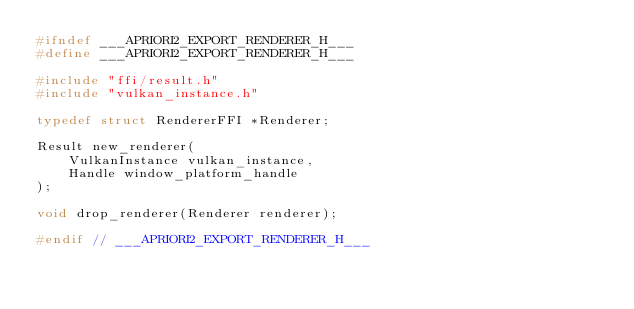Convert code to text. <code><loc_0><loc_0><loc_500><loc_500><_C_>#ifndef ___APRIORI2_EXPORT_RENDERER_H___
#define ___APRIORI2_EXPORT_RENDERER_H___

#include "ffi/result.h"
#include "vulkan_instance.h"

typedef struct RendererFFI *Renderer;

Result new_renderer(
    VulkanInstance vulkan_instance,
    Handle window_platform_handle
);

void drop_renderer(Renderer renderer);

#endif // ___APRIORI2_EXPORT_RENDERER_H___</code> 